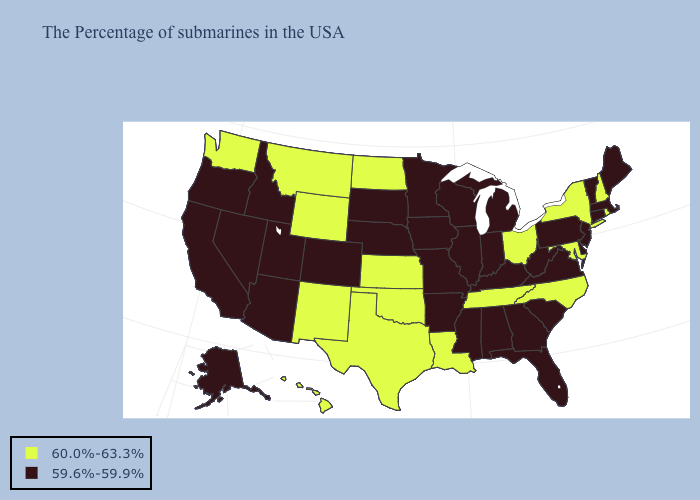Among the states that border Arizona , which have the highest value?
Concise answer only. New Mexico. Which states hav the highest value in the MidWest?
Short answer required. Ohio, Kansas, North Dakota. Does New Hampshire have the highest value in the Northeast?
Keep it brief. Yes. What is the lowest value in the USA?
Be succinct. 59.6%-59.9%. What is the value of Kansas?
Concise answer only. 60.0%-63.3%. Does Nevada have the highest value in the West?
Concise answer only. No. What is the highest value in states that border Michigan?
Concise answer only. 60.0%-63.3%. Does North Carolina have the highest value in the South?
Keep it brief. Yes. Does Louisiana have a higher value than Iowa?
Quick response, please. Yes. What is the value of Louisiana?
Concise answer only. 60.0%-63.3%. What is the highest value in states that border Mississippi?
Keep it brief. 60.0%-63.3%. What is the value of Alabama?
Write a very short answer. 59.6%-59.9%. What is the highest value in states that border Connecticut?
Write a very short answer. 60.0%-63.3%. Is the legend a continuous bar?
Give a very brief answer. No. 